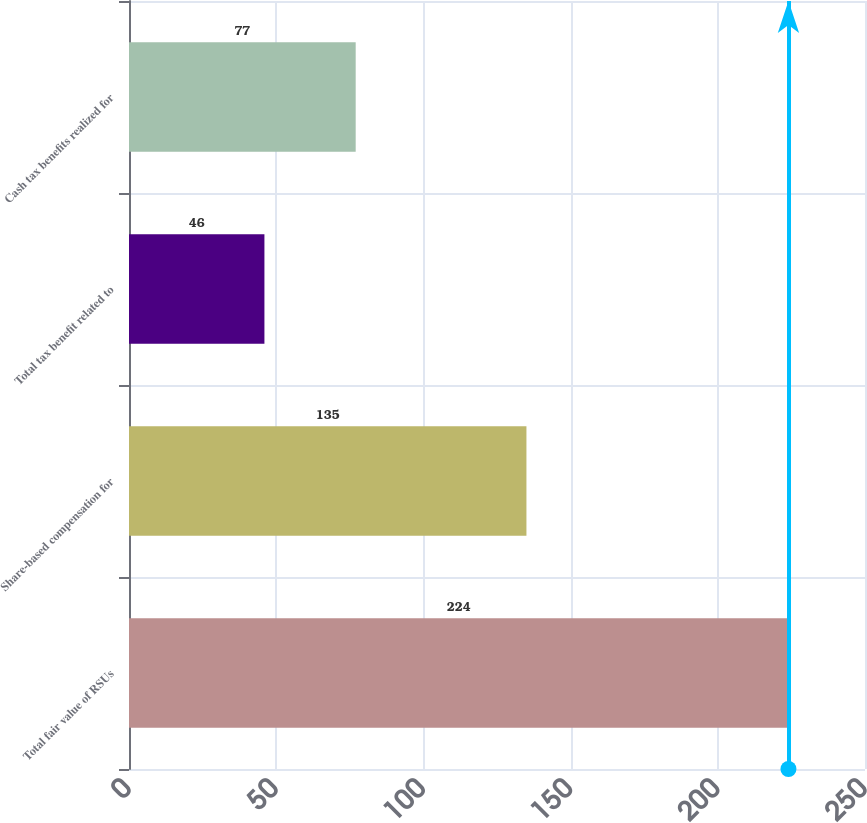Convert chart. <chart><loc_0><loc_0><loc_500><loc_500><bar_chart><fcel>Total fair value of RSUs<fcel>Share-based compensation for<fcel>Total tax benefit related to<fcel>Cash tax benefits realized for<nl><fcel>224<fcel>135<fcel>46<fcel>77<nl></chart> 